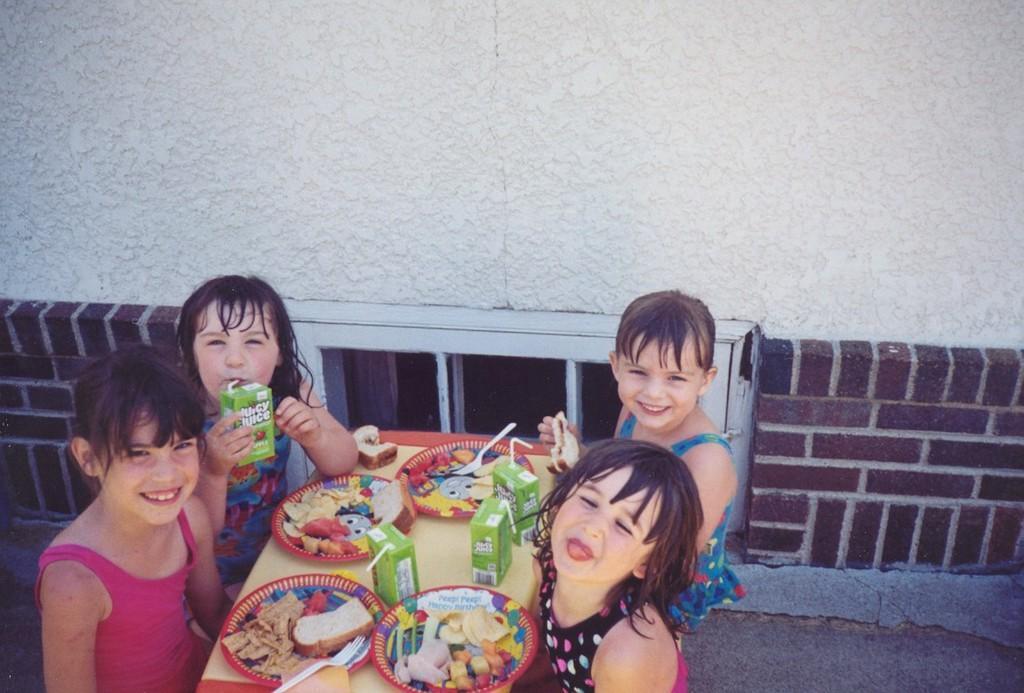Could you give a brief overview of what you see in this image? In the image there are four kids sitting around the table and there are some food items and juices served on the table, all the kids were smiling and posing for the photo and behind them there is a wall and there is a window in between the wall. 